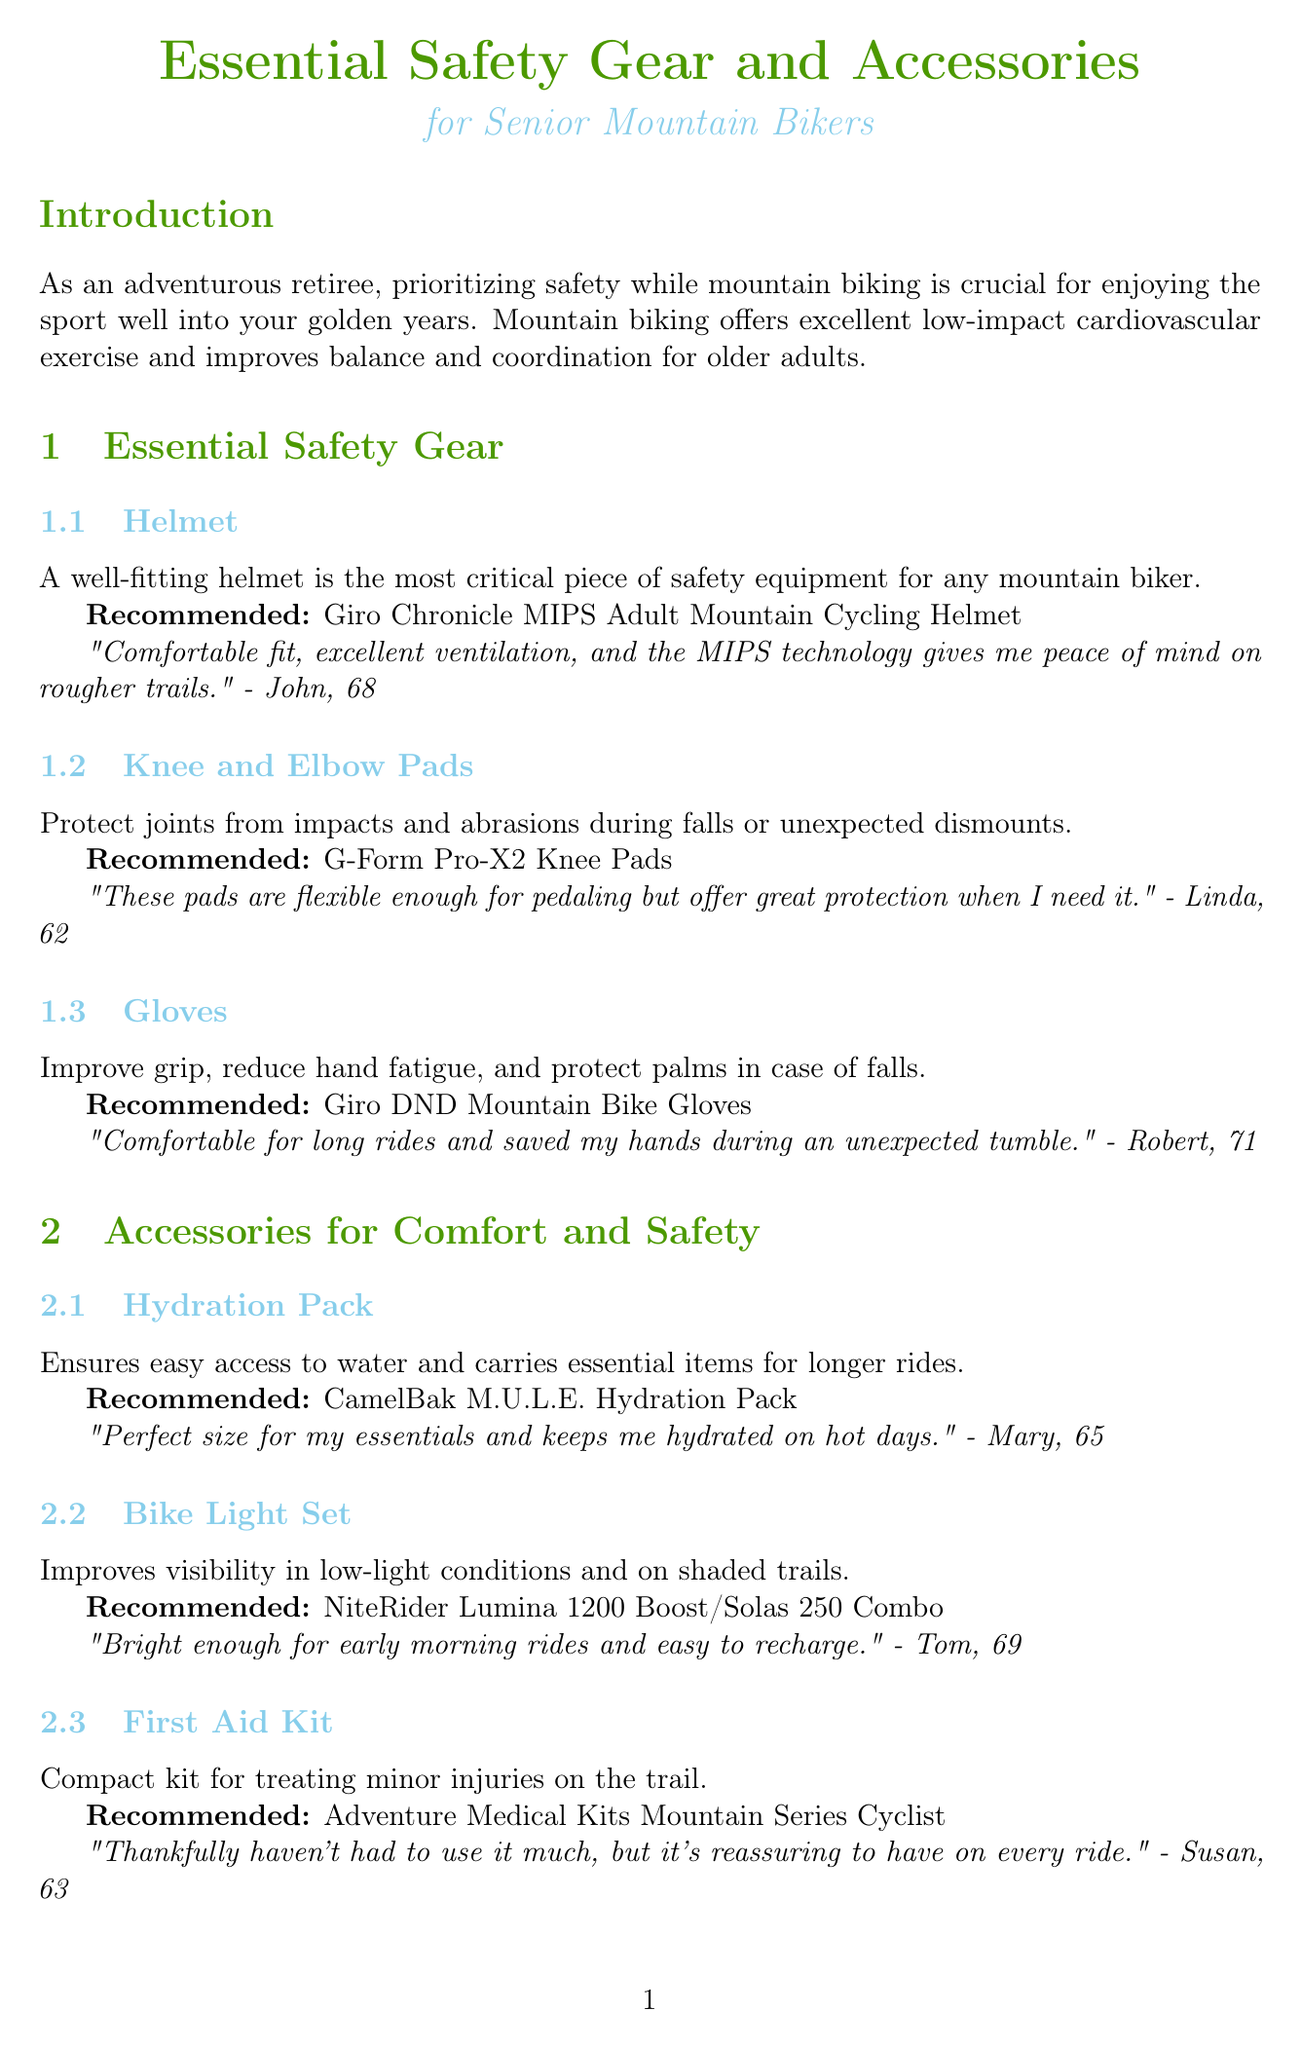What is the recommended helmet? The document lists the Giro Chronicle MIPS Adult Mountain Cycling Helmet as the recommended helmet for safety.
Answer: Giro Chronicle MIPS Adult Mountain Cycling Helmet How old is the user who reviewed the knee and elbow pads? Linda, who reviewed the knee and elbow pads, is mentioned to be 62 years old in the document.
Answer: 62 What is the main benefit of mountain biking for seniors? The document states that mountain biking offers excellent low-impact cardiovascular exercise and improves balance and coordination.
Answer: Low-impact cardiovascular exercise What product can help with navigation during rides? According to the document, the Garmin Edge 830 Mountain Bike Bundle is a recommended product for navigation.
Answer: Garmin Edge 830 Mountain Bike Bundle Which item is specifically recommended for arthritic hands? The Ergon GA3 Ergonomic Lock-on Bicycle Handlebar Grips are specifically recommended for reducing hand fatigue and improving comfort for arthritic hands.
Answer: Ergon GA3 Ergonomic Lock-on Bicycle Handlebar Grips What type of item is a hydration pack? The hydration pack is categorized under accessories for comfort and safety in the document.
Answer: Accessory What does the first aid kit provide? The first aid kit is described as a compact kit for treating minor injuries on the trail.
Answer: Minor injuries How many tools are mentioned in the multi-tool recommendation? The Crank Brothers M19 Multi-tool is noted to have all the tools needed for quick fixes, implying it has multiple tools.
Answer: Multiple tools What is the primary purpose of the emergency whistle? The document states that the emergency whistle serves as a simple but effective way to signal for help if needed.
Answer: Signal for help 